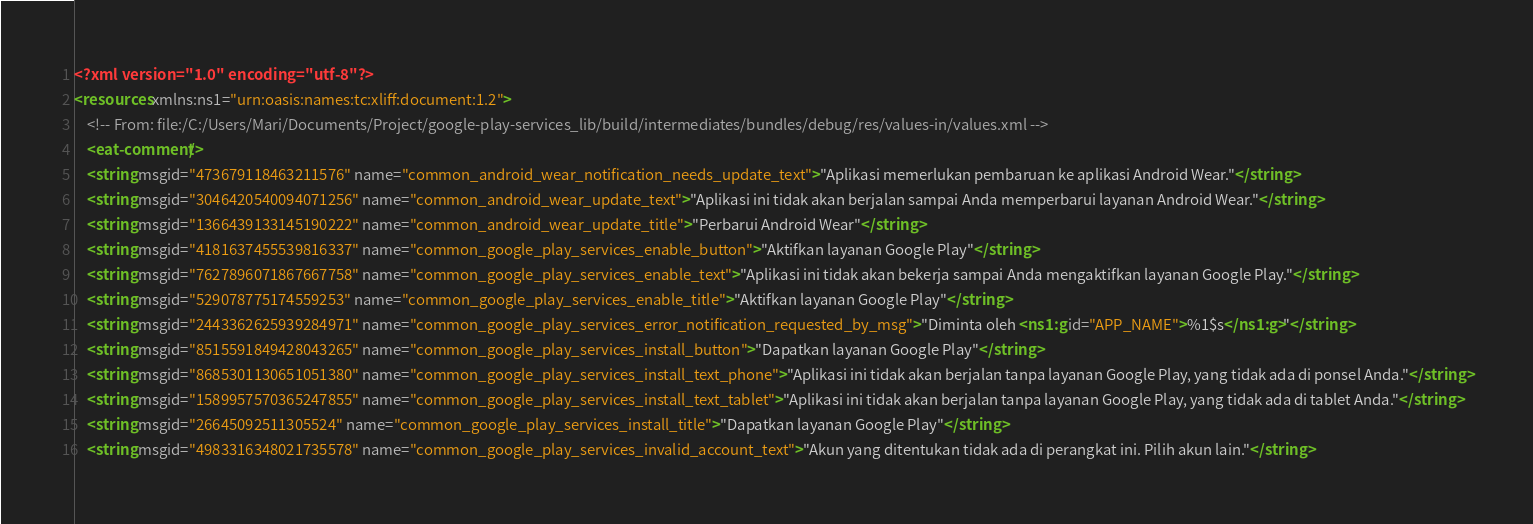Convert code to text. <code><loc_0><loc_0><loc_500><loc_500><_XML_><?xml version="1.0" encoding="utf-8"?>
<resources xmlns:ns1="urn:oasis:names:tc:xliff:document:1.2">
    <!-- From: file:/C:/Users/Mari/Documents/Project/google-play-services_lib/build/intermediates/bundles/debug/res/values-in/values.xml -->
    <eat-comment/>
    <string msgid="473679118463211576" name="common_android_wear_notification_needs_update_text">"Aplikasi memerlukan pembaruan ke aplikasi Android Wear."</string>
    <string msgid="3046420540094071256" name="common_android_wear_update_text">"Aplikasi ini tidak akan berjalan sampai Anda memperbarui layanan Android Wear."</string>
    <string msgid="1366439133145190222" name="common_android_wear_update_title">"Perbarui Android Wear"</string>
    <string msgid="4181637455539816337" name="common_google_play_services_enable_button">"Aktifkan layanan Google Play"</string>
    <string msgid="7627896071867667758" name="common_google_play_services_enable_text">"Aplikasi ini tidak akan bekerja sampai Anda mengaktifkan layanan Google Play."</string>
    <string msgid="529078775174559253" name="common_google_play_services_enable_title">"Aktifkan layanan Google Play"</string>
    <string msgid="2443362625939284971" name="common_google_play_services_error_notification_requested_by_msg">"Diminta oleh <ns1:g id="APP_NAME">%1$s</ns1:g>"</string>
    <string msgid="8515591849428043265" name="common_google_play_services_install_button">"Dapatkan layanan Google Play"</string>
    <string msgid="8685301130651051380" name="common_google_play_services_install_text_phone">"Aplikasi ini tidak akan berjalan tanpa layanan Google Play, yang tidak ada di ponsel Anda."</string>
    <string msgid="1589957570365247855" name="common_google_play_services_install_text_tablet">"Aplikasi ini tidak akan berjalan tanpa layanan Google Play, yang tidak ada di tablet Anda."</string>
    <string msgid="26645092511305524" name="common_google_play_services_install_title">"Dapatkan layanan Google Play"</string>
    <string msgid="4983316348021735578" name="common_google_play_services_invalid_account_text">"Akun yang ditentukan tidak ada di perangkat ini. Pilih akun lain."</string></code> 